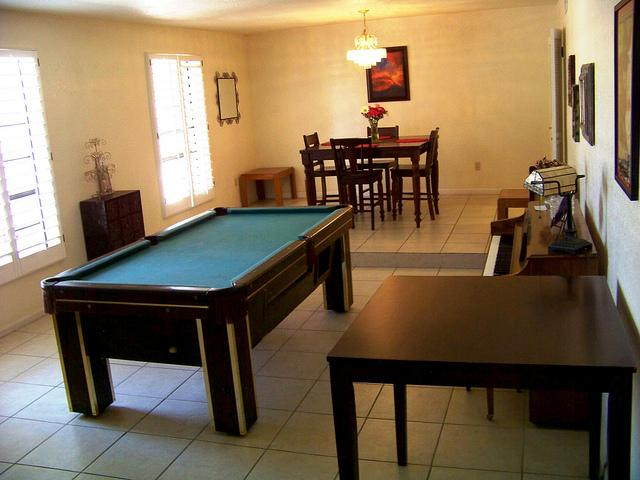What kind of room is this one?

Choices:
A) dining room
B) music room
C) karaoke room
D) recreation room recreation room 